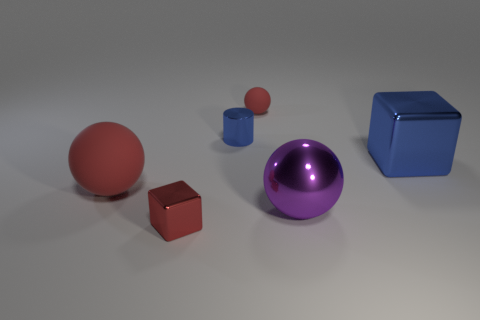Is the small sphere the same color as the tiny metallic cube?
Ensure brevity in your answer.  Yes. There is a big sphere that is the same color as the tiny rubber sphere; what is its material?
Your answer should be very brief. Rubber. The metal cube that is the same color as the shiny cylinder is what size?
Ensure brevity in your answer.  Large. Is the material of the large purple sphere the same as the blue thing that is to the left of the big cube?
Make the answer very short. Yes. What is the color of the tiny shiny object to the right of the small thing that is in front of the large blue object?
Provide a succinct answer. Blue. What size is the object that is both to the right of the tiny cylinder and in front of the big red object?
Provide a short and direct response. Large. What number of other objects are there of the same shape as the big rubber thing?
Make the answer very short. 2. Do the big purple shiny thing and the matte object right of the large rubber thing have the same shape?
Provide a succinct answer. Yes. What number of matte spheres are on the left side of the red shiny cube?
Keep it short and to the point. 1. There is a small thing in front of the purple sphere; is its shape the same as the large blue metal thing?
Your response must be concise. Yes. 